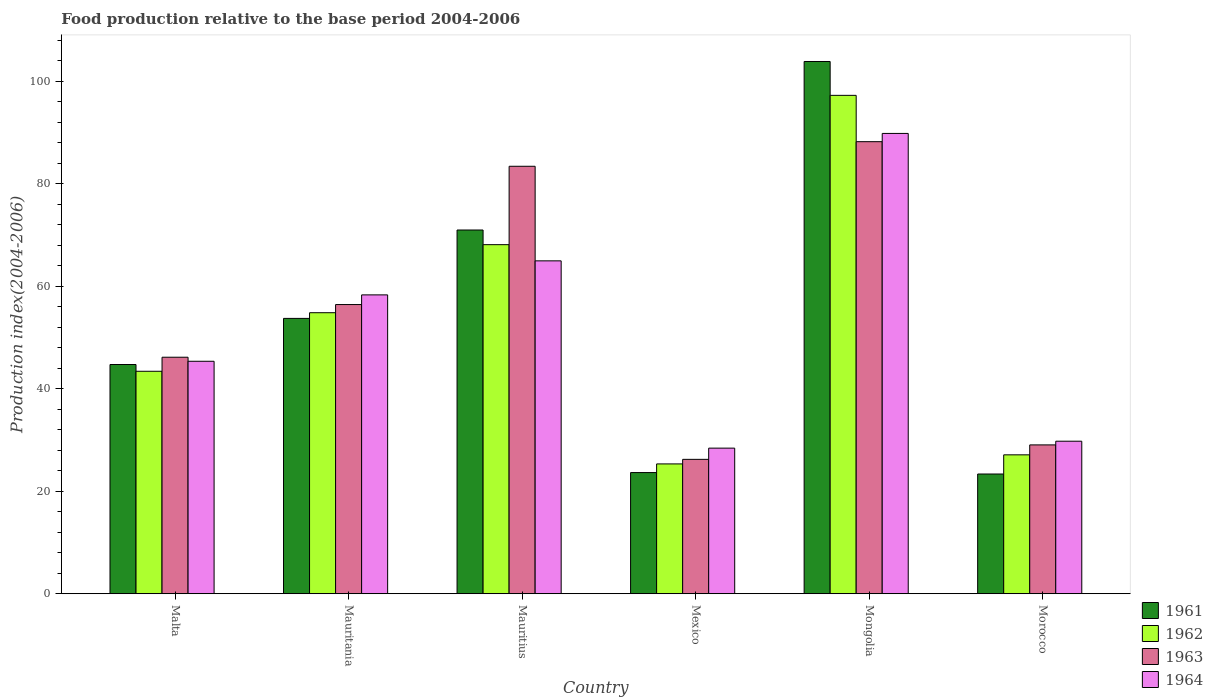How many bars are there on the 5th tick from the left?
Offer a terse response. 4. How many bars are there on the 3rd tick from the right?
Give a very brief answer. 4. What is the label of the 4th group of bars from the left?
Give a very brief answer. Mexico. What is the food production index in 1962 in Mauritius?
Offer a terse response. 68.13. Across all countries, what is the maximum food production index in 1962?
Your response must be concise. 97.27. Across all countries, what is the minimum food production index in 1962?
Your answer should be compact. 25.34. In which country was the food production index in 1961 maximum?
Make the answer very short. Mongolia. In which country was the food production index in 1964 minimum?
Give a very brief answer. Mexico. What is the total food production index in 1962 in the graph?
Your answer should be compact. 316.12. What is the difference between the food production index in 1963 in Malta and that in Mongolia?
Provide a short and direct response. -42.07. What is the difference between the food production index in 1961 in Mongolia and the food production index in 1963 in Malta?
Keep it short and to the point. 57.72. What is the average food production index in 1963 per country?
Your answer should be very brief. 54.92. What is the difference between the food production index of/in 1961 and food production index of/in 1962 in Mauritius?
Your answer should be compact. 2.86. What is the ratio of the food production index in 1962 in Malta to that in Mongolia?
Make the answer very short. 0.45. Is the difference between the food production index in 1961 in Malta and Mongolia greater than the difference between the food production index in 1962 in Malta and Mongolia?
Make the answer very short. No. What is the difference between the highest and the second highest food production index in 1964?
Your response must be concise. -24.87. What is the difference between the highest and the lowest food production index in 1962?
Keep it short and to the point. 71.93. In how many countries, is the food production index in 1962 greater than the average food production index in 1962 taken over all countries?
Offer a terse response. 3. Is the sum of the food production index in 1962 in Malta and Mauritania greater than the maximum food production index in 1963 across all countries?
Provide a short and direct response. Yes. How many bars are there?
Provide a succinct answer. 24. Are all the bars in the graph horizontal?
Your answer should be very brief. No. How many countries are there in the graph?
Give a very brief answer. 6. What is the difference between two consecutive major ticks on the Y-axis?
Ensure brevity in your answer.  20. Are the values on the major ticks of Y-axis written in scientific E-notation?
Offer a very short reply. No. Does the graph contain any zero values?
Your answer should be compact. No. Where does the legend appear in the graph?
Offer a very short reply. Bottom right. How many legend labels are there?
Offer a very short reply. 4. What is the title of the graph?
Offer a very short reply. Food production relative to the base period 2004-2006. Does "1985" appear as one of the legend labels in the graph?
Your response must be concise. No. What is the label or title of the X-axis?
Provide a succinct answer. Country. What is the label or title of the Y-axis?
Make the answer very short. Production index(2004-2006). What is the Production index(2004-2006) in 1961 in Malta?
Provide a short and direct response. 44.74. What is the Production index(2004-2006) of 1962 in Malta?
Your response must be concise. 43.42. What is the Production index(2004-2006) in 1963 in Malta?
Your response must be concise. 46.16. What is the Production index(2004-2006) of 1964 in Malta?
Your response must be concise. 45.37. What is the Production index(2004-2006) of 1961 in Mauritania?
Your response must be concise. 53.74. What is the Production index(2004-2006) in 1962 in Mauritania?
Ensure brevity in your answer.  54.85. What is the Production index(2004-2006) of 1963 in Mauritania?
Your answer should be compact. 56.44. What is the Production index(2004-2006) of 1964 in Mauritania?
Offer a terse response. 58.33. What is the Production index(2004-2006) in 1961 in Mauritius?
Ensure brevity in your answer.  70.99. What is the Production index(2004-2006) of 1962 in Mauritius?
Provide a short and direct response. 68.13. What is the Production index(2004-2006) in 1963 in Mauritius?
Ensure brevity in your answer.  83.43. What is the Production index(2004-2006) of 1964 in Mauritius?
Provide a short and direct response. 64.97. What is the Production index(2004-2006) of 1961 in Mexico?
Offer a very short reply. 23.65. What is the Production index(2004-2006) of 1962 in Mexico?
Offer a terse response. 25.34. What is the Production index(2004-2006) in 1963 in Mexico?
Provide a succinct answer. 26.23. What is the Production index(2004-2006) of 1964 in Mexico?
Keep it short and to the point. 28.42. What is the Production index(2004-2006) of 1961 in Mongolia?
Keep it short and to the point. 103.88. What is the Production index(2004-2006) of 1962 in Mongolia?
Ensure brevity in your answer.  97.27. What is the Production index(2004-2006) of 1963 in Mongolia?
Give a very brief answer. 88.23. What is the Production index(2004-2006) of 1964 in Mongolia?
Your answer should be compact. 89.84. What is the Production index(2004-2006) of 1961 in Morocco?
Keep it short and to the point. 23.37. What is the Production index(2004-2006) of 1962 in Morocco?
Offer a very short reply. 27.11. What is the Production index(2004-2006) of 1963 in Morocco?
Offer a terse response. 29.05. What is the Production index(2004-2006) in 1964 in Morocco?
Offer a very short reply. 29.77. Across all countries, what is the maximum Production index(2004-2006) of 1961?
Your response must be concise. 103.88. Across all countries, what is the maximum Production index(2004-2006) of 1962?
Offer a very short reply. 97.27. Across all countries, what is the maximum Production index(2004-2006) in 1963?
Provide a succinct answer. 88.23. Across all countries, what is the maximum Production index(2004-2006) of 1964?
Ensure brevity in your answer.  89.84. Across all countries, what is the minimum Production index(2004-2006) in 1961?
Your answer should be compact. 23.37. Across all countries, what is the minimum Production index(2004-2006) of 1962?
Keep it short and to the point. 25.34. Across all countries, what is the minimum Production index(2004-2006) in 1963?
Offer a terse response. 26.23. Across all countries, what is the minimum Production index(2004-2006) of 1964?
Your answer should be compact. 28.42. What is the total Production index(2004-2006) of 1961 in the graph?
Your answer should be compact. 320.37. What is the total Production index(2004-2006) of 1962 in the graph?
Make the answer very short. 316.12. What is the total Production index(2004-2006) of 1963 in the graph?
Make the answer very short. 329.54. What is the total Production index(2004-2006) of 1964 in the graph?
Provide a succinct answer. 316.7. What is the difference between the Production index(2004-2006) of 1962 in Malta and that in Mauritania?
Offer a very short reply. -11.43. What is the difference between the Production index(2004-2006) of 1963 in Malta and that in Mauritania?
Your answer should be compact. -10.28. What is the difference between the Production index(2004-2006) in 1964 in Malta and that in Mauritania?
Your response must be concise. -12.96. What is the difference between the Production index(2004-2006) in 1961 in Malta and that in Mauritius?
Ensure brevity in your answer.  -26.25. What is the difference between the Production index(2004-2006) of 1962 in Malta and that in Mauritius?
Keep it short and to the point. -24.71. What is the difference between the Production index(2004-2006) of 1963 in Malta and that in Mauritius?
Your response must be concise. -37.27. What is the difference between the Production index(2004-2006) of 1964 in Malta and that in Mauritius?
Make the answer very short. -19.6. What is the difference between the Production index(2004-2006) in 1961 in Malta and that in Mexico?
Your response must be concise. 21.09. What is the difference between the Production index(2004-2006) in 1962 in Malta and that in Mexico?
Your answer should be very brief. 18.08. What is the difference between the Production index(2004-2006) in 1963 in Malta and that in Mexico?
Ensure brevity in your answer.  19.93. What is the difference between the Production index(2004-2006) in 1964 in Malta and that in Mexico?
Keep it short and to the point. 16.95. What is the difference between the Production index(2004-2006) in 1961 in Malta and that in Mongolia?
Offer a terse response. -59.14. What is the difference between the Production index(2004-2006) in 1962 in Malta and that in Mongolia?
Offer a terse response. -53.85. What is the difference between the Production index(2004-2006) of 1963 in Malta and that in Mongolia?
Offer a terse response. -42.07. What is the difference between the Production index(2004-2006) in 1964 in Malta and that in Mongolia?
Offer a terse response. -44.47. What is the difference between the Production index(2004-2006) of 1961 in Malta and that in Morocco?
Make the answer very short. 21.37. What is the difference between the Production index(2004-2006) in 1962 in Malta and that in Morocco?
Keep it short and to the point. 16.31. What is the difference between the Production index(2004-2006) of 1963 in Malta and that in Morocco?
Your answer should be very brief. 17.11. What is the difference between the Production index(2004-2006) in 1961 in Mauritania and that in Mauritius?
Your answer should be very brief. -17.25. What is the difference between the Production index(2004-2006) in 1962 in Mauritania and that in Mauritius?
Provide a short and direct response. -13.28. What is the difference between the Production index(2004-2006) of 1963 in Mauritania and that in Mauritius?
Give a very brief answer. -26.99. What is the difference between the Production index(2004-2006) in 1964 in Mauritania and that in Mauritius?
Give a very brief answer. -6.64. What is the difference between the Production index(2004-2006) in 1961 in Mauritania and that in Mexico?
Give a very brief answer. 30.09. What is the difference between the Production index(2004-2006) of 1962 in Mauritania and that in Mexico?
Make the answer very short. 29.51. What is the difference between the Production index(2004-2006) of 1963 in Mauritania and that in Mexico?
Ensure brevity in your answer.  30.21. What is the difference between the Production index(2004-2006) of 1964 in Mauritania and that in Mexico?
Keep it short and to the point. 29.91. What is the difference between the Production index(2004-2006) in 1961 in Mauritania and that in Mongolia?
Ensure brevity in your answer.  -50.14. What is the difference between the Production index(2004-2006) in 1962 in Mauritania and that in Mongolia?
Provide a short and direct response. -42.42. What is the difference between the Production index(2004-2006) in 1963 in Mauritania and that in Mongolia?
Your response must be concise. -31.79. What is the difference between the Production index(2004-2006) of 1964 in Mauritania and that in Mongolia?
Offer a terse response. -31.51. What is the difference between the Production index(2004-2006) of 1961 in Mauritania and that in Morocco?
Make the answer very short. 30.37. What is the difference between the Production index(2004-2006) of 1962 in Mauritania and that in Morocco?
Provide a short and direct response. 27.74. What is the difference between the Production index(2004-2006) in 1963 in Mauritania and that in Morocco?
Offer a very short reply. 27.39. What is the difference between the Production index(2004-2006) of 1964 in Mauritania and that in Morocco?
Give a very brief answer. 28.56. What is the difference between the Production index(2004-2006) of 1961 in Mauritius and that in Mexico?
Keep it short and to the point. 47.34. What is the difference between the Production index(2004-2006) of 1962 in Mauritius and that in Mexico?
Provide a succinct answer. 42.79. What is the difference between the Production index(2004-2006) in 1963 in Mauritius and that in Mexico?
Keep it short and to the point. 57.2. What is the difference between the Production index(2004-2006) in 1964 in Mauritius and that in Mexico?
Give a very brief answer. 36.55. What is the difference between the Production index(2004-2006) in 1961 in Mauritius and that in Mongolia?
Your answer should be very brief. -32.89. What is the difference between the Production index(2004-2006) of 1962 in Mauritius and that in Mongolia?
Provide a short and direct response. -29.14. What is the difference between the Production index(2004-2006) in 1964 in Mauritius and that in Mongolia?
Provide a short and direct response. -24.87. What is the difference between the Production index(2004-2006) of 1961 in Mauritius and that in Morocco?
Provide a short and direct response. 47.62. What is the difference between the Production index(2004-2006) in 1962 in Mauritius and that in Morocco?
Offer a terse response. 41.02. What is the difference between the Production index(2004-2006) in 1963 in Mauritius and that in Morocco?
Keep it short and to the point. 54.38. What is the difference between the Production index(2004-2006) in 1964 in Mauritius and that in Morocco?
Your response must be concise. 35.2. What is the difference between the Production index(2004-2006) in 1961 in Mexico and that in Mongolia?
Keep it short and to the point. -80.23. What is the difference between the Production index(2004-2006) of 1962 in Mexico and that in Mongolia?
Give a very brief answer. -71.93. What is the difference between the Production index(2004-2006) in 1963 in Mexico and that in Mongolia?
Your answer should be compact. -62. What is the difference between the Production index(2004-2006) of 1964 in Mexico and that in Mongolia?
Keep it short and to the point. -61.42. What is the difference between the Production index(2004-2006) of 1961 in Mexico and that in Morocco?
Offer a very short reply. 0.28. What is the difference between the Production index(2004-2006) of 1962 in Mexico and that in Morocco?
Your response must be concise. -1.77. What is the difference between the Production index(2004-2006) in 1963 in Mexico and that in Morocco?
Your response must be concise. -2.82. What is the difference between the Production index(2004-2006) of 1964 in Mexico and that in Morocco?
Provide a short and direct response. -1.35. What is the difference between the Production index(2004-2006) in 1961 in Mongolia and that in Morocco?
Provide a succinct answer. 80.51. What is the difference between the Production index(2004-2006) of 1962 in Mongolia and that in Morocco?
Your response must be concise. 70.16. What is the difference between the Production index(2004-2006) in 1963 in Mongolia and that in Morocco?
Offer a terse response. 59.18. What is the difference between the Production index(2004-2006) of 1964 in Mongolia and that in Morocco?
Provide a succinct answer. 60.07. What is the difference between the Production index(2004-2006) in 1961 in Malta and the Production index(2004-2006) in 1962 in Mauritania?
Your response must be concise. -10.11. What is the difference between the Production index(2004-2006) of 1961 in Malta and the Production index(2004-2006) of 1963 in Mauritania?
Give a very brief answer. -11.7. What is the difference between the Production index(2004-2006) of 1961 in Malta and the Production index(2004-2006) of 1964 in Mauritania?
Offer a very short reply. -13.59. What is the difference between the Production index(2004-2006) in 1962 in Malta and the Production index(2004-2006) in 1963 in Mauritania?
Your response must be concise. -13.02. What is the difference between the Production index(2004-2006) in 1962 in Malta and the Production index(2004-2006) in 1964 in Mauritania?
Give a very brief answer. -14.91. What is the difference between the Production index(2004-2006) in 1963 in Malta and the Production index(2004-2006) in 1964 in Mauritania?
Your answer should be very brief. -12.17. What is the difference between the Production index(2004-2006) of 1961 in Malta and the Production index(2004-2006) of 1962 in Mauritius?
Give a very brief answer. -23.39. What is the difference between the Production index(2004-2006) in 1961 in Malta and the Production index(2004-2006) in 1963 in Mauritius?
Offer a very short reply. -38.69. What is the difference between the Production index(2004-2006) in 1961 in Malta and the Production index(2004-2006) in 1964 in Mauritius?
Make the answer very short. -20.23. What is the difference between the Production index(2004-2006) of 1962 in Malta and the Production index(2004-2006) of 1963 in Mauritius?
Offer a terse response. -40.01. What is the difference between the Production index(2004-2006) in 1962 in Malta and the Production index(2004-2006) in 1964 in Mauritius?
Make the answer very short. -21.55. What is the difference between the Production index(2004-2006) in 1963 in Malta and the Production index(2004-2006) in 1964 in Mauritius?
Provide a short and direct response. -18.81. What is the difference between the Production index(2004-2006) in 1961 in Malta and the Production index(2004-2006) in 1962 in Mexico?
Your response must be concise. 19.4. What is the difference between the Production index(2004-2006) of 1961 in Malta and the Production index(2004-2006) of 1963 in Mexico?
Provide a short and direct response. 18.51. What is the difference between the Production index(2004-2006) in 1961 in Malta and the Production index(2004-2006) in 1964 in Mexico?
Give a very brief answer. 16.32. What is the difference between the Production index(2004-2006) in 1962 in Malta and the Production index(2004-2006) in 1963 in Mexico?
Make the answer very short. 17.19. What is the difference between the Production index(2004-2006) in 1963 in Malta and the Production index(2004-2006) in 1964 in Mexico?
Keep it short and to the point. 17.74. What is the difference between the Production index(2004-2006) in 1961 in Malta and the Production index(2004-2006) in 1962 in Mongolia?
Provide a short and direct response. -52.53. What is the difference between the Production index(2004-2006) in 1961 in Malta and the Production index(2004-2006) in 1963 in Mongolia?
Your response must be concise. -43.49. What is the difference between the Production index(2004-2006) of 1961 in Malta and the Production index(2004-2006) of 1964 in Mongolia?
Your answer should be compact. -45.1. What is the difference between the Production index(2004-2006) in 1962 in Malta and the Production index(2004-2006) in 1963 in Mongolia?
Give a very brief answer. -44.81. What is the difference between the Production index(2004-2006) in 1962 in Malta and the Production index(2004-2006) in 1964 in Mongolia?
Your response must be concise. -46.42. What is the difference between the Production index(2004-2006) of 1963 in Malta and the Production index(2004-2006) of 1964 in Mongolia?
Keep it short and to the point. -43.68. What is the difference between the Production index(2004-2006) in 1961 in Malta and the Production index(2004-2006) in 1962 in Morocco?
Offer a terse response. 17.63. What is the difference between the Production index(2004-2006) in 1961 in Malta and the Production index(2004-2006) in 1963 in Morocco?
Offer a terse response. 15.69. What is the difference between the Production index(2004-2006) in 1961 in Malta and the Production index(2004-2006) in 1964 in Morocco?
Ensure brevity in your answer.  14.97. What is the difference between the Production index(2004-2006) of 1962 in Malta and the Production index(2004-2006) of 1963 in Morocco?
Ensure brevity in your answer.  14.37. What is the difference between the Production index(2004-2006) in 1962 in Malta and the Production index(2004-2006) in 1964 in Morocco?
Your response must be concise. 13.65. What is the difference between the Production index(2004-2006) in 1963 in Malta and the Production index(2004-2006) in 1964 in Morocco?
Offer a very short reply. 16.39. What is the difference between the Production index(2004-2006) of 1961 in Mauritania and the Production index(2004-2006) of 1962 in Mauritius?
Keep it short and to the point. -14.39. What is the difference between the Production index(2004-2006) in 1961 in Mauritania and the Production index(2004-2006) in 1963 in Mauritius?
Offer a very short reply. -29.69. What is the difference between the Production index(2004-2006) of 1961 in Mauritania and the Production index(2004-2006) of 1964 in Mauritius?
Ensure brevity in your answer.  -11.23. What is the difference between the Production index(2004-2006) in 1962 in Mauritania and the Production index(2004-2006) in 1963 in Mauritius?
Your answer should be compact. -28.58. What is the difference between the Production index(2004-2006) in 1962 in Mauritania and the Production index(2004-2006) in 1964 in Mauritius?
Offer a very short reply. -10.12. What is the difference between the Production index(2004-2006) in 1963 in Mauritania and the Production index(2004-2006) in 1964 in Mauritius?
Provide a short and direct response. -8.53. What is the difference between the Production index(2004-2006) of 1961 in Mauritania and the Production index(2004-2006) of 1962 in Mexico?
Your answer should be very brief. 28.4. What is the difference between the Production index(2004-2006) in 1961 in Mauritania and the Production index(2004-2006) in 1963 in Mexico?
Offer a terse response. 27.51. What is the difference between the Production index(2004-2006) in 1961 in Mauritania and the Production index(2004-2006) in 1964 in Mexico?
Your answer should be compact. 25.32. What is the difference between the Production index(2004-2006) of 1962 in Mauritania and the Production index(2004-2006) of 1963 in Mexico?
Your answer should be very brief. 28.62. What is the difference between the Production index(2004-2006) of 1962 in Mauritania and the Production index(2004-2006) of 1964 in Mexico?
Ensure brevity in your answer.  26.43. What is the difference between the Production index(2004-2006) in 1963 in Mauritania and the Production index(2004-2006) in 1964 in Mexico?
Give a very brief answer. 28.02. What is the difference between the Production index(2004-2006) of 1961 in Mauritania and the Production index(2004-2006) of 1962 in Mongolia?
Make the answer very short. -43.53. What is the difference between the Production index(2004-2006) in 1961 in Mauritania and the Production index(2004-2006) in 1963 in Mongolia?
Your response must be concise. -34.49. What is the difference between the Production index(2004-2006) in 1961 in Mauritania and the Production index(2004-2006) in 1964 in Mongolia?
Your answer should be very brief. -36.1. What is the difference between the Production index(2004-2006) in 1962 in Mauritania and the Production index(2004-2006) in 1963 in Mongolia?
Give a very brief answer. -33.38. What is the difference between the Production index(2004-2006) in 1962 in Mauritania and the Production index(2004-2006) in 1964 in Mongolia?
Your answer should be compact. -34.99. What is the difference between the Production index(2004-2006) of 1963 in Mauritania and the Production index(2004-2006) of 1964 in Mongolia?
Ensure brevity in your answer.  -33.4. What is the difference between the Production index(2004-2006) in 1961 in Mauritania and the Production index(2004-2006) in 1962 in Morocco?
Keep it short and to the point. 26.63. What is the difference between the Production index(2004-2006) of 1961 in Mauritania and the Production index(2004-2006) of 1963 in Morocco?
Give a very brief answer. 24.69. What is the difference between the Production index(2004-2006) of 1961 in Mauritania and the Production index(2004-2006) of 1964 in Morocco?
Offer a terse response. 23.97. What is the difference between the Production index(2004-2006) of 1962 in Mauritania and the Production index(2004-2006) of 1963 in Morocco?
Your answer should be very brief. 25.8. What is the difference between the Production index(2004-2006) in 1962 in Mauritania and the Production index(2004-2006) in 1964 in Morocco?
Provide a succinct answer. 25.08. What is the difference between the Production index(2004-2006) in 1963 in Mauritania and the Production index(2004-2006) in 1964 in Morocco?
Offer a very short reply. 26.67. What is the difference between the Production index(2004-2006) of 1961 in Mauritius and the Production index(2004-2006) of 1962 in Mexico?
Offer a very short reply. 45.65. What is the difference between the Production index(2004-2006) of 1961 in Mauritius and the Production index(2004-2006) of 1963 in Mexico?
Your answer should be compact. 44.76. What is the difference between the Production index(2004-2006) of 1961 in Mauritius and the Production index(2004-2006) of 1964 in Mexico?
Your answer should be compact. 42.57. What is the difference between the Production index(2004-2006) of 1962 in Mauritius and the Production index(2004-2006) of 1963 in Mexico?
Keep it short and to the point. 41.9. What is the difference between the Production index(2004-2006) of 1962 in Mauritius and the Production index(2004-2006) of 1964 in Mexico?
Make the answer very short. 39.71. What is the difference between the Production index(2004-2006) of 1963 in Mauritius and the Production index(2004-2006) of 1964 in Mexico?
Offer a very short reply. 55.01. What is the difference between the Production index(2004-2006) in 1961 in Mauritius and the Production index(2004-2006) in 1962 in Mongolia?
Your response must be concise. -26.28. What is the difference between the Production index(2004-2006) in 1961 in Mauritius and the Production index(2004-2006) in 1963 in Mongolia?
Make the answer very short. -17.24. What is the difference between the Production index(2004-2006) of 1961 in Mauritius and the Production index(2004-2006) of 1964 in Mongolia?
Keep it short and to the point. -18.85. What is the difference between the Production index(2004-2006) in 1962 in Mauritius and the Production index(2004-2006) in 1963 in Mongolia?
Give a very brief answer. -20.1. What is the difference between the Production index(2004-2006) in 1962 in Mauritius and the Production index(2004-2006) in 1964 in Mongolia?
Ensure brevity in your answer.  -21.71. What is the difference between the Production index(2004-2006) in 1963 in Mauritius and the Production index(2004-2006) in 1964 in Mongolia?
Your answer should be very brief. -6.41. What is the difference between the Production index(2004-2006) of 1961 in Mauritius and the Production index(2004-2006) of 1962 in Morocco?
Ensure brevity in your answer.  43.88. What is the difference between the Production index(2004-2006) of 1961 in Mauritius and the Production index(2004-2006) of 1963 in Morocco?
Provide a succinct answer. 41.94. What is the difference between the Production index(2004-2006) of 1961 in Mauritius and the Production index(2004-2006) of 1964 in Morocco?
Offer a terse response. 41.22. What is the difference between the Production index(2004-2006) of 1962 in Mauritius and the Production index(2004-2006) of 1963 in Morocco?
Give a very brief answer. 39.08. What is the difference between the Production index(2004-2006) in 1962 in Mauritius and the Production index(2004-2006) in 1964 in Morocco?
Make the answer very short. 38.36. What is the difference between the Production index(2004-2006) of 1963 in Mauritius and the Production index(2004-2006) of 1964 in Morocco?
Offer a terse response. 53.66. What is the difference between the Production index(2004-2006) of 1961 in Mexico and the Production index(2004-2006) of 1962 in Mongolia?
Your answer should be compact. -73.62. What is the difference between the Production index(2004-2006) in 1961 in Mexico and the Production index(2004-2006) in 1963 in Mongolia?
Your answer should be compact. -64.58. What is the difference between the Production index(2004-2006) of 1961 in Mexico and the Production index(2004-2006) of 1964 in Mongolia?
Ensure brevity in your answer.  -66.19. What is the difference between the Production index(2004-2006) of 1962 in Mexico and the Production index(2004-2006) of 1963 in Mongolia?
Give a very brief answer. -62.89. What is the difference between the Production index(2004-2006) in 1962 in Mexico and the Production index(2004-2006) in 1964 in Mongolia?
Give a very brief answer. -64.5. What is the difference between the Production index(2004-2006) in 1963 in Mexico and the Production index(2004-2006) in 1964 in Mongolia?
Offer a terse response. -63.61. What is the difference between the Production index(2004-2006) of 1961 in Mexico and the Production index(2004-2006) of 1962 in Morocco?
Make the answer very short. -3.46. What is the difference between the Production index(2004-2006) in 1961 in Mexico and the Production index(2004-2006) in 1964 in Morocco?
Offer a very short reply. -6.12. What is the difference between the Production index(2004-2006) of 1962 in Mexico and the Production index(2004-2006) of 1963 in Morocco?
Your answer should be very brief. -3.71. What is the difference between the Production index(2004-2006) in 1962 in Mexico and the Production index(2004-2006) in 1964 in Morocco?
Ensure brevity in your answer.  -4.43. What is the difference between the Production index(2004-2006) of 1963 in Mexico and the Production index(2004-2006) of 1964 in Morocco?
Your response must be concise. -3.54. What is the difference between the Production index(2004-2006) of 1961 in Mongolia and the Production index(2004-2006) of 1962 in Morocco?
Provide a short and direct response. 76.77. What is the difference between the Production index(2004-2006) in 1961 in Mongolia and the Production index(2004-2006) in 1963 in Morocco?
Give a very brief answer. 74.83. What is the difference between the Production index(2004-2006) in 1961 in Mongolia and the Production index(2004-2006) in 1964 in Morocco?
Keep it short and to the point. 74.11. What is the difference between the Production index(2004-2006) in 1962 in Mongolia and the Production index(2004-2006) in 1963 in Morocco?
Make the answer very short. 68.22. What is the difference between the Production index(2004-2006) in 1962 in Mongolia and the Production index(2004-2006) in 1964 in Morocco?
Your answer should be very brief. 67.5. What is the difference between the Production index(2004-2006) in 1963 in Mongolia and the Production index(2004-2006) in 1964 in Morocco?
Give a very brief answer. 58.46. What is the average Production index(2004-2006) in 1961 per country?
Ensure brevity in your answer.  53.4. What is the average Production index(2004-2006) in 1962 per country?
Your response must be concise. 52.69. What is the average Production index(2004-2006) in 1963 per country?
Offer a terse response. 54.92. What is the average Production index(2004-2006) in 1964 per country?
Keep it short and to the point. 52.78. What is the difference between the Production index(2004-2006) of 1961 and Production index(2004-2006) of 1962 in Malta?
Your answer should be compact. 1.32. What is the difference between the Production index(2004-2006) of 1961 and Production index(2004-2006) of 1963 in Malta?
Your response must be concise. -1.42. What is the difference between the Production index(2004-2006) of 1961 and Production index(2004-2006) of 1964 in Malta?
Your answer should be compact. -0.63. What is the difference between the Production index(2004-2006) of 1962 and Production index(2004-2006) of 1963 in Malta?
Your response must be concise. -2.74. What is the difference between the Production index(2004-2006) of 1962 and Production index(2004-2006) of 1964 in Malta?
Your answer should be very brief. -1.95. What is the difference between the Production index(2004-2006) in 1963 and Production index(2004-2006) in 1964 in Malta?
Give a very brief answer. 0.79. What is the difference between the Production index(2004-2006) in 1961 and Production index(2004-2006) in 1962 in Mauritania?
Your answer should be very brief. -1.11. What is the difference between the Production index(2004-2006) in 1961 and Production index(2004-2006) in 1964 in Mauritania?
Ensure brevity in your answer.  -4.59. What is the difference between the Production index(2004-2006) of 1962 and Production index(2004-2006) of 1963 in Mauritania?
Give a very brief answer. -1.59. What is the difference between the Production index(2004-2006) of 1962 and Production index(2004-2006) of 1964 in Mauritania?
Offer a terse response. -3.48. What is the difference between the Production index(2004-2006) in 1963 and Production index(2004-2006) in 1964 in Mauritania?
Keep it short and to the point. -1.89. What is the difference between the Production index(2004-2006) in 1961 and Production index(2004-2006) in 1962 in Mauritius?
Your response must be concise. 2.86. What is the difference between the Production index(2004-2006) in 1961 and Production index(2004-2006) in 1963 in Mauritius?
Offer a terse response. -12.44. What is the difference between the Production index(2004-2006) of 1961 and Production index(2004-2006) of 1964 in Mauritius?
Offer a very short reply. 6.02. What is the difference between the Production index(2004-2006) of 1962 and Production index(2004-2006) of 1963 in Mauritius?
Your answer should be compact. -15.3. What is the difference between the Production index(2004-2006) in 1962 and Production index(2004-2006) in 1964 in Mauritius?
Your answer should be very brief. 3.16. What is the difference between the Production index(2004-2006) in 1963 and Production index(2004-2006) in 1964 in Mauritius?
Provide a short and direct response. 18.46. What is the difference between the Production index(2004-2006) in 1961 and Production index(2004-2006) in 1962 in Mexico?
Provide a succinct answer. -1.69. What is the difference between the Production index(2004-2006) of 1961 and Production index(2004-2006) of 1963 in Mexico?
Your response must be concise. -2.58. What is the difference between the Production index(2004-2006) of 1961 and Production index(2004-2006) of 1964 in Mexico?
Give a very brief answer. -4.77. What is the difference between the Production index(2004-2006) in 1962 and Production index(2004-2006) in 1963 in Mexico?
Provide a short and direct response. -0.89. What is the difference between the Production index(2004-2006) in 1962 and Production index(2004-2006) in 1964 in Mexico?
Your answer should be compact. -3.08. What is the difference between the Production index(2004-2006) of 1963 and Production index(2004-2006) of 1964 in Mexico?
Provide a short and direct response. -2.19. What is the difference between the Production index(2004-2006) in 1961 and Production index(2004-2006) in 1962 in Mongolia?
Keep it short and to the point. 6.61. What is the difference between the Production index(2004-2006) of 1961 and Production index(2004-2006) of 1963 in Mongolia?
Provide a short and direct response. 15.65. What is the difference between the Production index(2004-2006) in 1961 and Production index(2004-2006) in 1964 in Mongolia?
Keep it short and to the point. 14.04. What is the difference between the Production index(2004-2006) of 1962 and Production index(2004-2006) of 1963 in Mongolia?
Give a very brief answer. 9.04. What is the difference between the Production index(2004-2006) in 1962 and Production index(2004-2006) in 1964 in Mongolia?
Keep it short and to the point. 7.43. What is the difference between the Production index(2004-2006) of 1963 and Production index(2004-2006) of 1964 in Mongolia?
Provide a short and direct response. -1.61. What is the difference between the Production index(2004-2006) of 1961 and Production index(2004-2006) of 1962 in Morocco?
Give a very brief answer. -3.74. What is the difference between the Production index(2004-2006) of 1961 and Production index(2004-2006) of 1963 in Morocco?
Your answer should be very brief. -5.68. What is the difference between the Production index(2004-2006) of 1961 and Production index(2004-2006) of 1964 in Morocco?
Provide a succinct answer. -6.4. What is the difference between the Production index(2004-2006) of 1962 and Production index(2004-2006) of 1963 in Morocco?
Make the answer very short. -1.94. What is the difference between the Production index(2004-2006) of 1962 and Production index(2004-2006) of 1964 in Morocco?
Give a very brief answer. -2.66. What is the difference between the Production index(2004-2006) of 1963 and Production index(2004-2006) of 1964 in Morocco?
Ensure brevity in your answer.  -0.72. What is the ratio of the Production index(2004-2006) in 1961 in Malta to that in Mauritania?
Your answer should be very brief. 0.83. What is the ratio of the Production index(2004-2006) in 1962 in Malta to that in Mauritania?
Offer a very short reply. 0.79. What is the ratio of the Production index(2004-2006) in 1963 in Malta to that in Mauritania?
Give a very brief answer. 0.82. What is the ratio of the Production index(2004-2006) of 1964 in Malta to that in Mauritania?
Keep it short and to the point. 0.78. What is the ratio of the Production index(2004-2006) in 1961 in Malta to that in Mauritius?
Your answer should be compact. 0.63. What is the ratio of the Production index(2004-2006) of 1962 in Malta to that in Mauritius?
Provide a succinct answer. 0.64. What is the ratio of the Production index(2004-2006) of 1963 in Malta to that in Mauritius?
Your answer should be compact. 0.55. What is the ratio of the Production index(2004-2006) of 1964 in Malta to that in Mauritius?
Offer a very short reply. 0.7. What is the ratio of the Production index(2004-2006) in 1961 in Malta to that in Mexico?
Your answer should be very brief. 1.89. What is the ratio of the Production index(2004-2006) in 1962 in Malta to that in Mexico?
Provide a short and direct response. 1.71. What is the ratio of the Production index(2004-2006) of 1963 in Malta to that in Mexico?
Offer a very short reply. 1.76. What is the ratio of the Production index(2004-2006) in 1964 in Malta to that in Mexico?
Give a very brief answer. 1.6. What is the ratio of the Production index(2004-2006) in 1961 in Malta to that in Mongolia?
Give a very brief answer. 0.43. What is the ratio of the Production index(2004-2006) in 1962 in Malta to that in Mongolia?
Offer a terse response. 0.45. What is the ratio of the Production index(2004-2006) in 1963 in Malta to that in Mongolia?
Offer a very short reply. 0.52. What is the ratio of the Production index(2004-2006) of 1964 in Malta to that in Mongolia?
Ensure brevity in your answer.  0.51. What is the ratio of the Production index(2004-2006) in 1961 in Malta to that in Morocco?
Your answer should be compact. 1.91. What is the ratio of the Production index(2004-2006) of 1962 in Malta to that in Morocco?
Offer a very short reply. 1.6. What is the ratio of the Production index(2004-2006) of 1963 in Malta to that in Morocco?
Ensure brevity in your answer.  1.59. What is the ratio of the Production index(2004-2006) of 1964 in Malta to that in Morocco?
Give a very brief answer. 1.52. What is the ratio of the Production index(2004-2006) in 1961 in Mauritania to that in Mauritius?
Your answer should be very brief. 0.76. What is the ratio of the Production index(2004-2006) in 1962 in Mauritania to that in Mauritius?
Your answer should be compact. 0.81. What is the ratio of the Production index(2004-2006) of 1963 in Mauritania to that in Mauritius?
Your answer should be very brief. 0.68. What is the ratio of the Production index(2004-2006) in 1964 in Mauritania to that in Mauritius?
Provide a short and direct response. 0.9. What is the ratio of the Production index(2004-2006) in 1961 in Mauritania to that in Mexico?
Give a very brief answer. 2.27. What is the ratio of the Production index(2004-2006) of 1962 in Mauritania to that in Mexico?
Provide a succinct answer. 2.16. What is the ratio of the Production index(2004-2006) in 1963 in Mauritania to that in Mexico?
Your response must be concise. 2.15. What is the ratio of the Production index(2004-2006) in 1964 in Mauritania to that in Mexico?
Offer a terse response. 2.05. What is the ratio of the Production index(2004-2006) of 1961 in Mauritania to that in Mongolia?
Give a very brief answer. 0.52. What is the ratio of the Production index(2004-2006) of 1962 in Mauritania to that in Mongolia?
Offer a terse response. 0.56. What is the ratio of the Production index(2004-2006) of 1963 in Mauritania to that in Mongolia?
Make the answer very short. 0.64. What is the ratio of the Production index(2004-2006) in 1964 in Mauritania to that in Mongolia?
Provide a short and direct response. 0.65. What is the ratio of the Production index(2004-2006) in 1961 in Mauritania to that in Morocco?
Your answer should be very brief. 2.3. What is the ratio of the Production index(2004-2006) of 1962 in Mauritania to that in Morocco?
Ensure brevity in your answer.  2.02. What is the ratio of the Production index(2004-2006) in 1963 in Mauritania to that in Morocco?
Offer a terse response. 1.94. What is the ratio of the Production index(2004-2006) in 1964 in Mauritania to that in Morocco?
Provide a succinct answer. 1.96. What is the ratio of the Production index(2004-2006) of 1961 in Mauritius to that in Mexico?
Offer a very short reply. 3. What is the ratio of the Production index(2004-2006) in 1962 in Mauritius to that in Mexico?
Your answer should be compact. 2.69. What is the ratio of the Production index(2004-2006) of 1963 in Mauritius to that in Mexico?
Keep it short and to the point. 3.18. What is the ratio of the Production index(2004-2006) of 1964 in Mauritius to that in Mexico?
Provide a short and direct response. 2.29. What is the ratio of the Production index(2004-2006) in 1961 in Mauritius to that in Mongolia?
Offer a terse response. 0.68. What is the ratio of the Production index(2004-2006) of 1962 in Mauritius to that in Mongolia?
Keep it short and to the point. 0.7. What is the ratio of the Production index(2004-2006) of 1963 in Mauritius to that in Mongolia?
Provide a succinct answer. 0.95. What is the ratio of the Production index(2004-2006) in 1964 in Mauritius to that in Mongolia?
Provide a succinct answer. 0.72. What is the ratio of the Production index(2004-2006) in 1961 in Mauritius to that in Morocco?
Keep it short and to the point. 3.04. What is the ratio of the Production index(2004-2006) of 1962 in Mauritius to that in Morocco?
Your answer should be compact. 2.51. What is the ratio of the Production index(2004-2006) of 1963 in Mauritius to that in Morocco?
Offer a very short reply. 2.87. What is the ratio of the Production index(2004-2006) in 1964 in Mauritius to that in Morocco?
Offer a terse response. 2.18. What is the ratio of the Production index(2004-2006) in 1961 in Mexico to that in Mongolia?
Your answer should be very brief. 0.23. What is the ratio of the Production index(2004-2006) in 1962 in Mexico to that in Mongolia?
Your response must be concise. 0.26. What is the ratio of the Production index(2004-2006) of 1963 in Mexico to that in Mongolia?
Keep it short and to the point. 0.3. What is the ratio of the Production index(2004-2006) in 1964 in Mexico to that in Mongolia?
Provide a succinct answer. 0.32. What is the ratio of the Production index(2004-2006) of 1961 in Mexico to that in Morocco?
Offer a terse response. 1.01. What is the ratio of the Production index(2004-2006) of 1962 in Mexico to that in Morocco?
Provide a short and direct response. 0.93. What is the ratio of the Production index(2004-2006) of 1963 in Mexico to that in Morocco?
Ensure brevity in your answer.  0.9. What is the ratio of the Production index(2004-2006) in 1964 in Mexico to that in Morocco?
Offer a very short reply. 0.95. What is the ratio of the Production index(2004-2006) of 1961 in Mongolia to that in Morocco?
Offer a terse response. 4.45. What is the ratio of the Production index(2004-2006) of 1962 in Mongolia to that in Morocco?
Provide a short and direct response. 3.59. What is the ratio of the Production index(2004-2006) of 1963 in Mongolia to that in Morocco?
Provide a short and direct response. 3.04. What is the ratio of the Production index(2004-2006) in 1964 in Mongolia to that in Morocco?
Ensure brevity in your answer.  3.02. What is the difference between the highest and the second highest Production index(2004-2006) in 1961?
Make the answer very short. 32.89. What is the difference between the highest and the second highest Production index(2004-2006) in 1962?
Your response must be concise. 29.14. What is the difference between the highest and the second highest Production index(2004-2006) of 1964?
Provide a succinct answer. 24.87. What is the difference between the highest and the lowest Production index(2004-2006) of 1961?
Keep it short and to the point. 80.51. What is the difference between the highest and the lowest Production index(2004-2006) in 1962?
Offer a very short reply. 71.93. What is the difference between the highest and the lowest Production index(2004-2006) of 1964?
Your answer should be very brief. 61.42. 